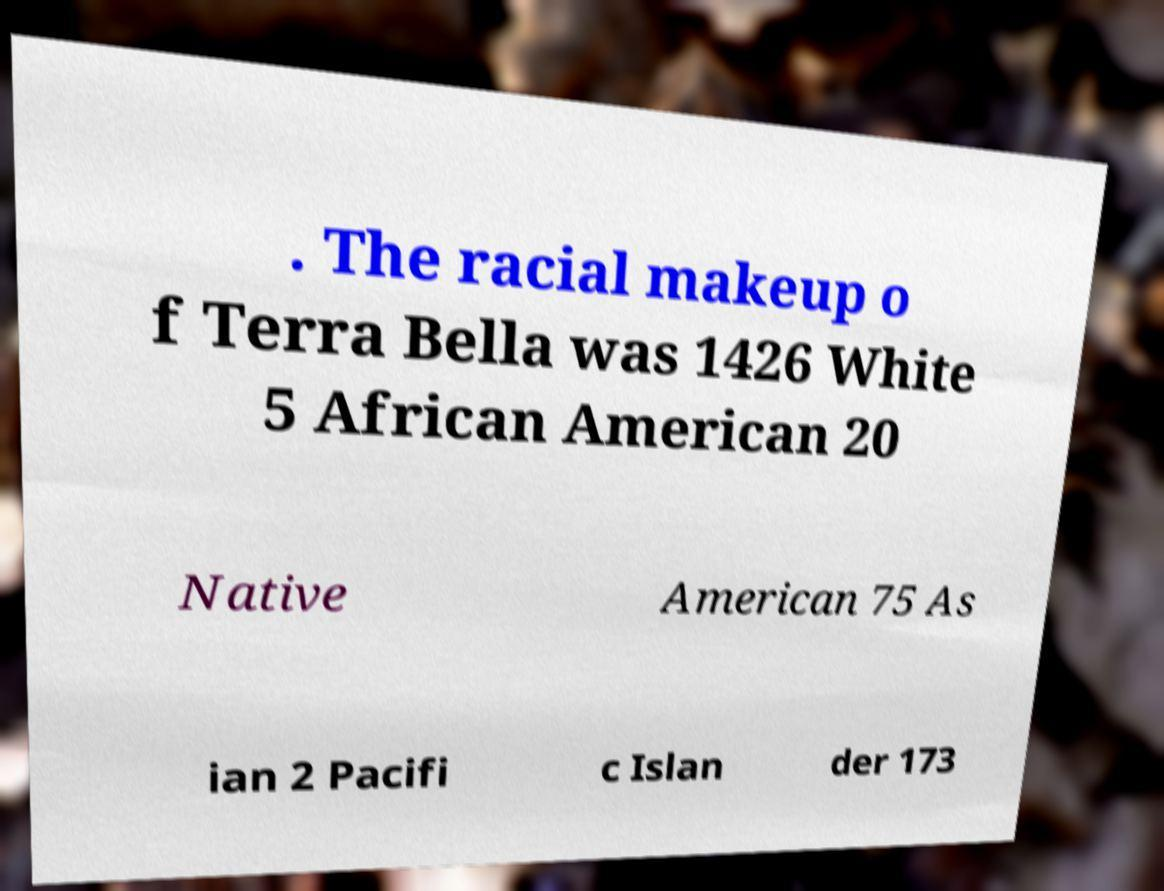What messages or text are displayed in this image? I need them in a readable, typed format. . The racial makeup o f Terra Bella was 1426 White 5 African American 20 Native American 75 As ian 2 Pacifi c Islan der 173 